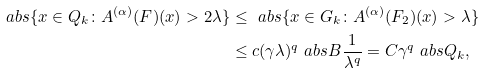Convert formula to latex. <formula><loc_0><loc_0><loc_500><loc_500>\ a b s { \{ x \in Q _ { k } \colon A ^ { ( \alpha ) } ( F ) ( x ) > 2 \lambda \} } & \leq \ a b s { \{ x \in G _ { k } \colon A ^ { ( \alpha ) } ( F _ { 2 } ) ( x ) > \lambda \} } \\ & \leq c ( \gamma \lambda ) ^ { q } \ a b s { B } \frac { 1 } { \lambda ^ { q } } = C \gamma ^ { q } \ a b s { Q _ { k } } ,</formula> 